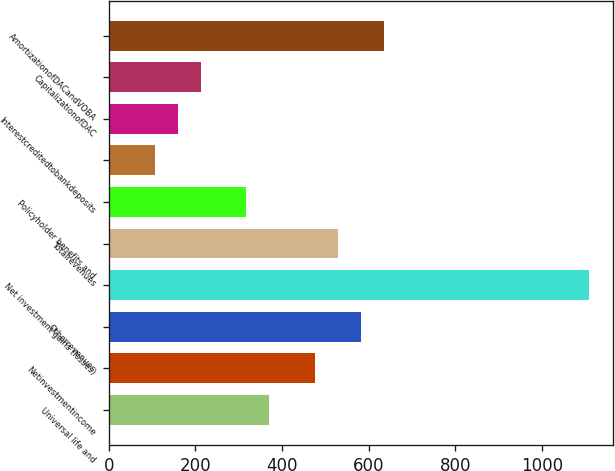Convert chart to OTSL. <chart><loc_0><loc_0><loc_500><loc_500><bar_chart><fcel>Universal life and<fcel>Netinvestmentincome<fcel>Otherrevenues<fcel>Net investment gains (losses)<fcel>Totalrevenues<fcel>Policyholder benefits and<fcel>Unnamed: 6<fcel>Interestcreditedtobankdeposits<fcel>CapitalizationofDAC<fcel>AmortizationofDACandVOBA<nl><fcel>370.44<fcel>476.08<fcel>581.72<fcel>1109.92<fcel>528.9<fcel>317.62<fcel>106.34<fcel>159.16<fcel>211.98<fcel>634.54<nl></chart> 